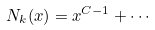Convert formula to latex. <formula><loc_0><loc_0><loc_500><loc_500>N _ { k } ( x ) = x ^ { C - 1 } + \cdots</formula> 